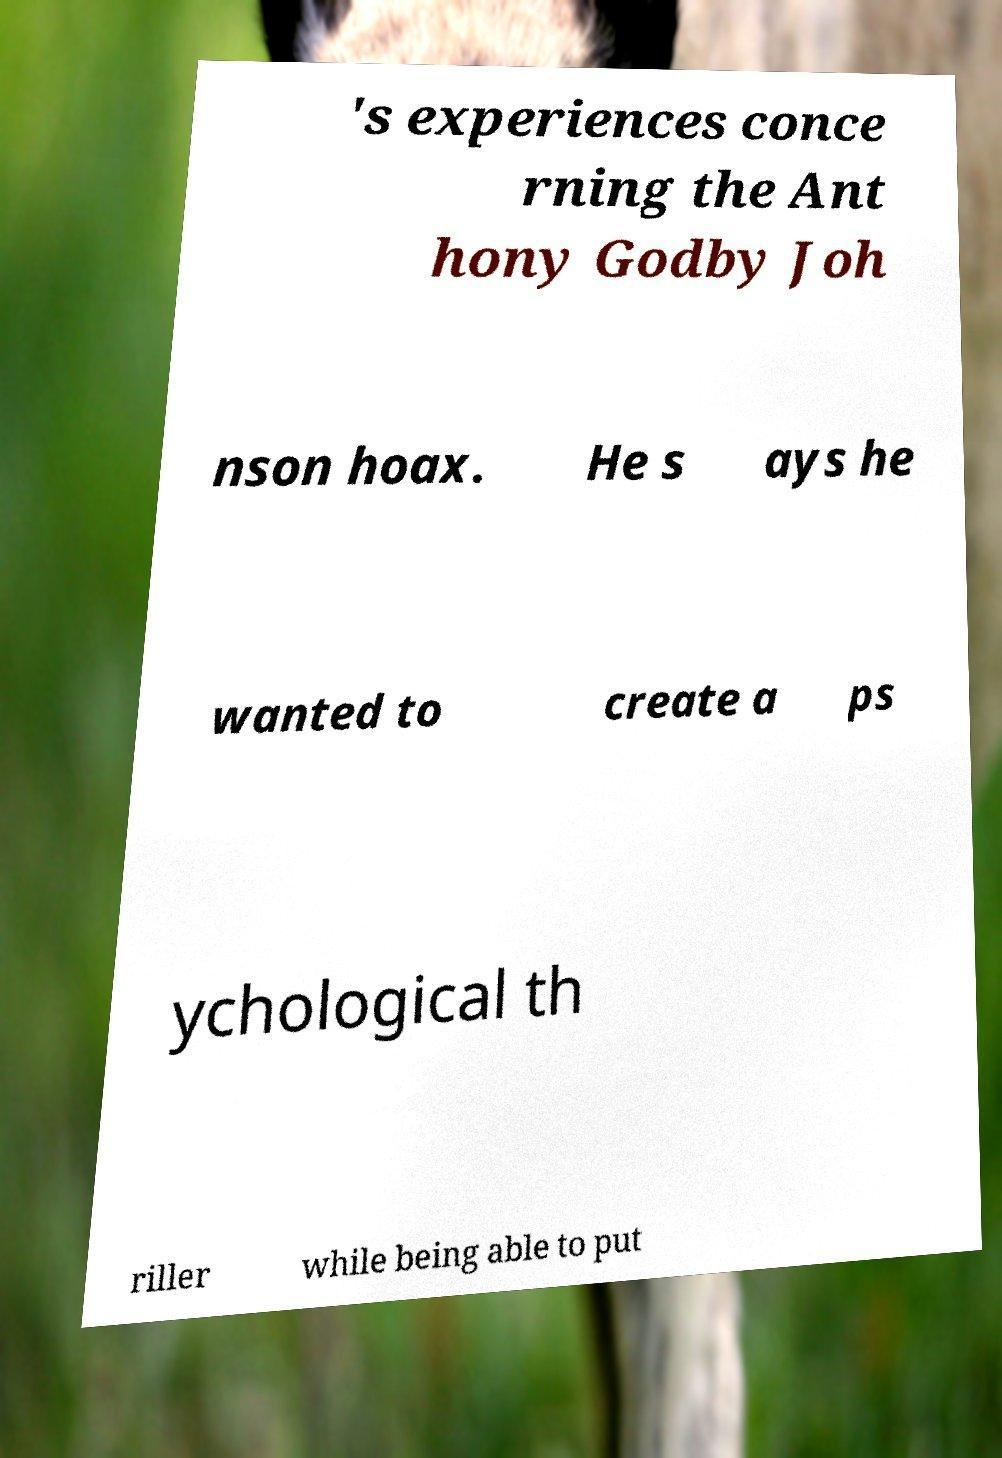What messages or text are displayed in this image? I need them in a readable, typed format. 's experiences conce rning the Ant hony Godby Joh nson hoax. He s ays he wanted to create a ps ychological th riller while being able to put 